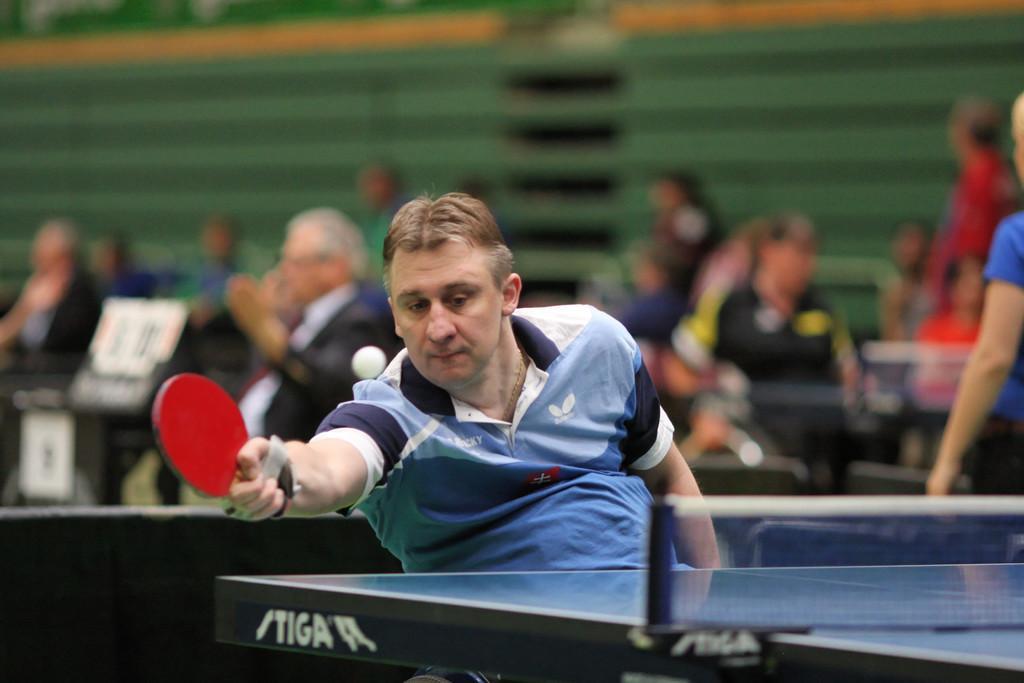How would you summarize this image in a sentence or two? In this image I can see a man playing table tennis game. this man is holding a table tennis bat which is red in color. He is wearing blue T-Shirt and this is a table tennis. At background I can see people sitting. 